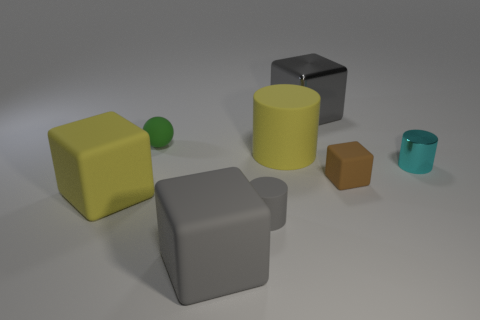Subtract all tiny rubber cubes. How many cubes are left? 3 Add 2 cylinders. How many objects exist? 10 Subtract all brown cubes. How many cubes are left? 3 Subtract 1 brown blocks. How many objects are left? 7 Subtract all cylinders. How many objects are left? 5 Subtract 2 cylinders. How many cylinders are left? 1 Subtract all green cubes. Subtract all yellow cylinders. How many cubes are left? 4 Subtract all gray cylinders. How many yellow cubes are left? 1 Subtract all brown rubber objects. Subtract all small cyan objects. How many objects are left? 6 Add 3 big gray rubber things. How many big gray rubber things are left? 4 